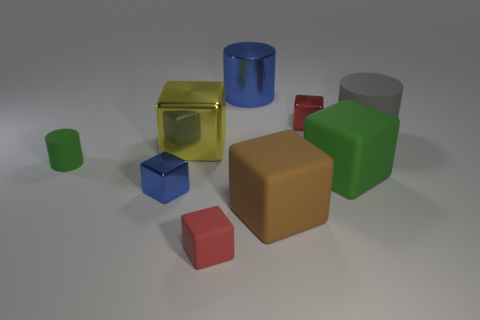There is a green object that is on the right side of the blue shiny thing that is in front of the gray cylinder; what is its material?
Provide a succinct answer. Rubber. Are there any large brown objects that have the same shape as the large blue object?
Give a very brief answer. No. What shape is the big gray matte thing?
Give a very brief answer. Cylinder. What material is the large object behind the large cylinder on the right side of the tiny red block that is on the right side of the large blue metal thing?
Offer a very short reply. Metal. Are there more red cubes in front of the tiny red matte object than big gray matte cylinders?
Your response must be concise. No. There is a green thing that is the same size as the yellow metallic block; what material is it?
Give a very brief answer. Rubber. Are there any red things of the same size as the brown cube?
Your answer should be compact. No. There is a green thing that is on the left side of the blue shiny cylinder; what is its size?
Make the answer very short. Small. How big is the blue cube?
Ensure brevity in your answer.  Small. How many blocks are big yellow things or small rubber things?
Your response must be concise. 2. 